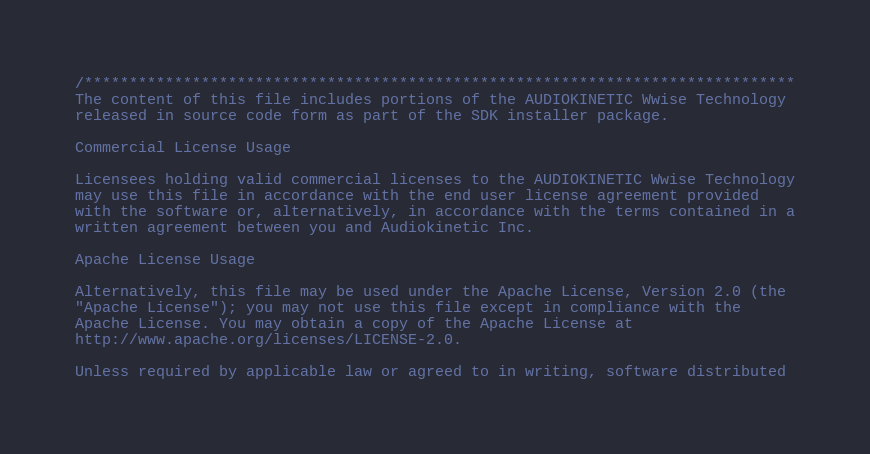<code> <loc_0><loc_0><loc_500><loc_500><_C_>/*******************************************************************************
The content of this file includes portions of the AUDIOKINETIC Wwise Technology
released in source code form as part of the SDK installer package.

Commercial License Usage

Licensees holding valid commercial licenses to the AUDIOKINETIC Wwise Technology
may use this file in accordance with the end user license agreement provided 
with the software or, alternatively, in accordance with the terms contained in a
written agreement between you and Audiokinetic Inc.

Apache License Usage

Alternatively, this file may be used under the Apache License, Version 2.0 (the 
"Apache License"); you may not use this file except in compliance with the 
Apache License. You may obtain a copy of the Apache License at 
http://www.apache.org/licenses/LICENSE-2.0.

Unless required by applicable law or agreed to in writing, software distributed</code> 